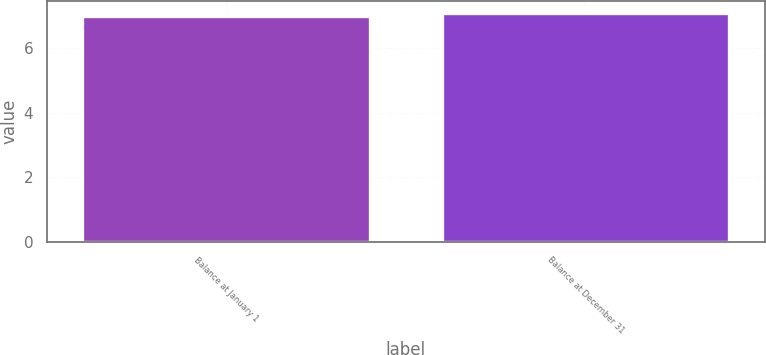Convert chart to OTSL. <chart><loc_0><loc_0><loc_500><loc_500><bar_chart><fcel>Balance at January 1<fcel>Balance at December 31<nl><fcel>7<fcel>7.1<nl></chart> 